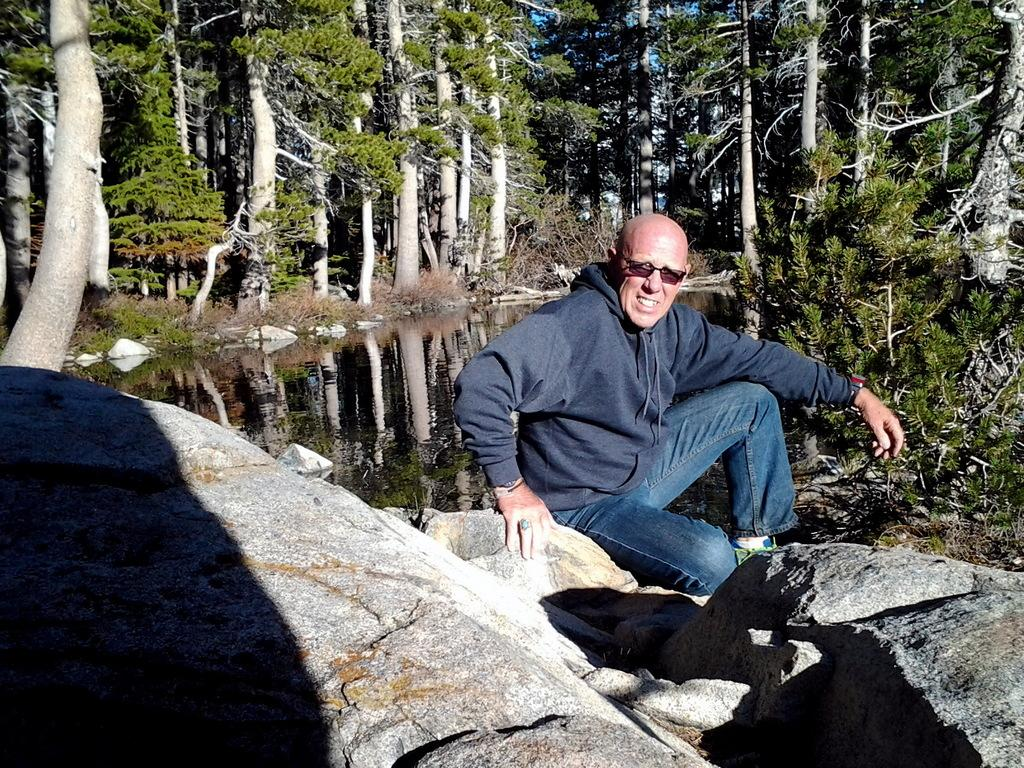What is the main subject of the image? The main subject of the image is a man. Can you describe the man's attire? The man is wearing clothes, shoes, a finger ring, a wrist watch, and goggles. What is the man doing in the image? The man is sitting. What other elements can be seen in the image? There are stones, a rock, water, and trees visible in the image. What type of root can be seen growing from the man's back in the image? There is no root growing from the man's back in the image. How many toes are visible on the man's feet in the image? The image does not show the man's toes, so it cannot be determined from the image. 